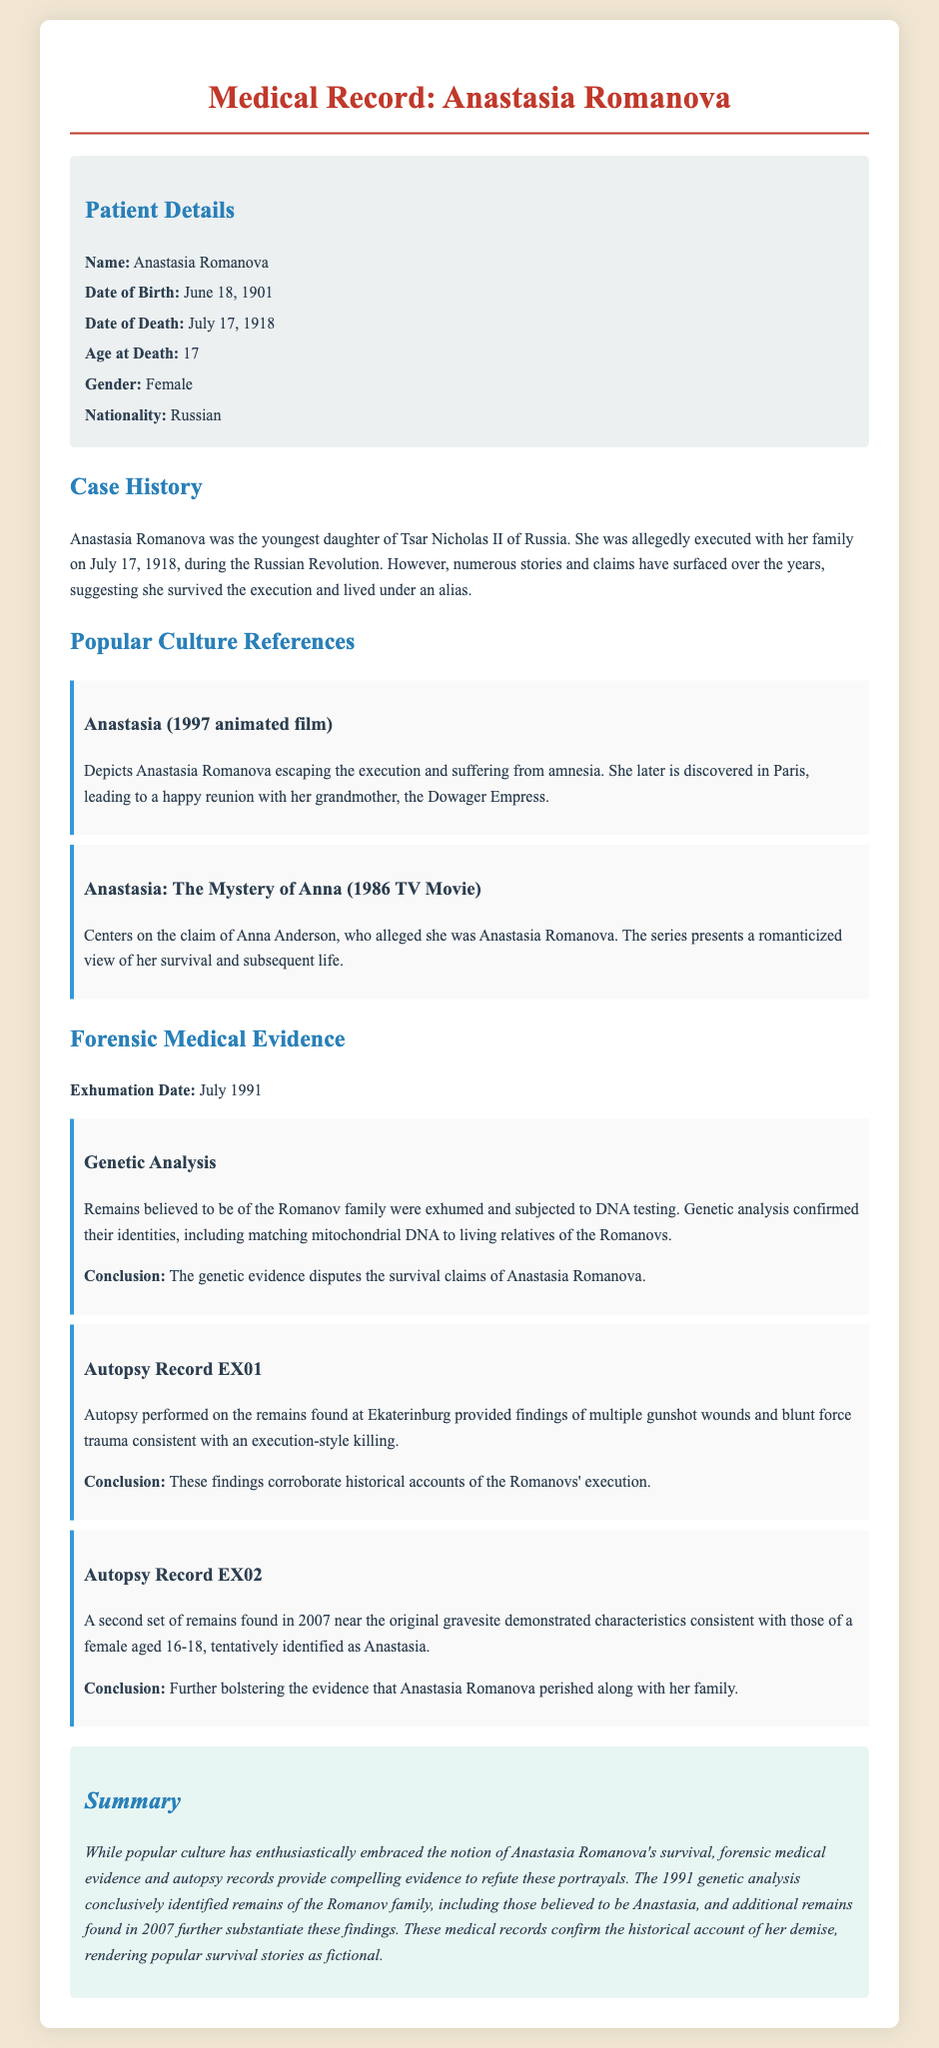What is the name of the patient? The patient's name is stated in the patient details section of the document.
Answer: Anastasia Romanova What was Anastasia's age at death? The age at death is directly mentioned in the patient details of the document.
Answer: 17 When was the exhumation of the remains conducted? The exhumation date is specified in the forensic medical evidence section of the document.
Answer: July 1991 What was found in the second autopsy record? The content of the second autopsy record reveals important findings about the remains, which is summarized in that section.
Answer: Characteristics consistent with a female aged 16-18 Which animated film depicts Anastasia escaping execution? The title of the animated film is mentioned in the popular culture references of the document.
Answer: Anastasia (1997 animated film) What conclusion does genetic analysis provide regarding Anastasia's survival claims? The conclusion reached is highlighted within the forensic medical evidence section, summarizing its implications on survival claims.
Answer: Disputes the survival claims What type of trauma was identified in the autopsy record EX01? The type of trauma is documented in the forensic medical evidence that pertains to the assessment of the remains.
Answer: Multiple gunshot wounds and blunt force trauma What is the summary's stance on popular survival stories? The summary offers a clear perspective on popular survival narratives based on medical evidence found within the document.
Answer: Fictional 